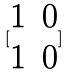<formula> <loc_0><loc_0><loc_500><loc_500>[ \begin{matrix} 1 & 0 \\ 1 & 0 \end{matrix} ]</formula> 